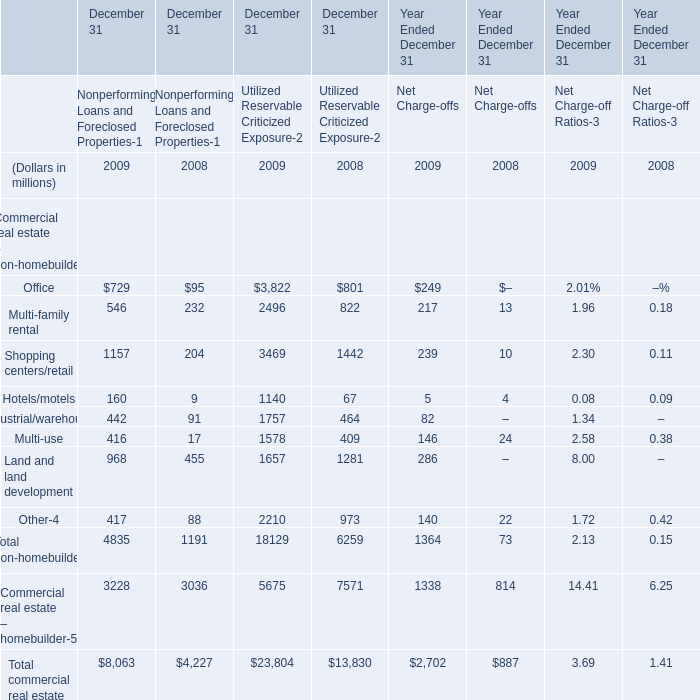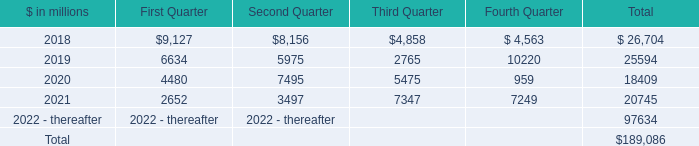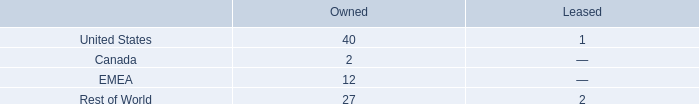In the year with largest amount of Office for Nonperforming Loans and Foreclosed Propertiesthe , what's the increasing rate of Multi-family rental for Nonperforming Loans and Foreclosed Propertiesthe ? 
Computations: ((546 - 232) / 232)
Answer: 1.35345. 